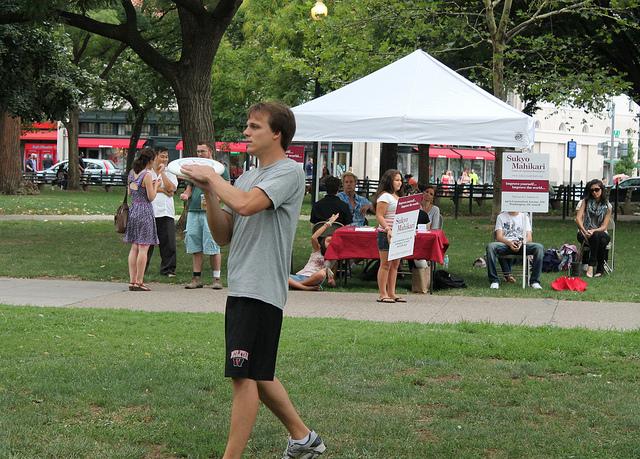Is this a protest?
Keep it brief. No. What is he carrying?
Short answer required. Frisbee. What is the girl holding?
Quick response, please. Sign. What does the man have in his hands?
Answer briefly. Frisbee. 